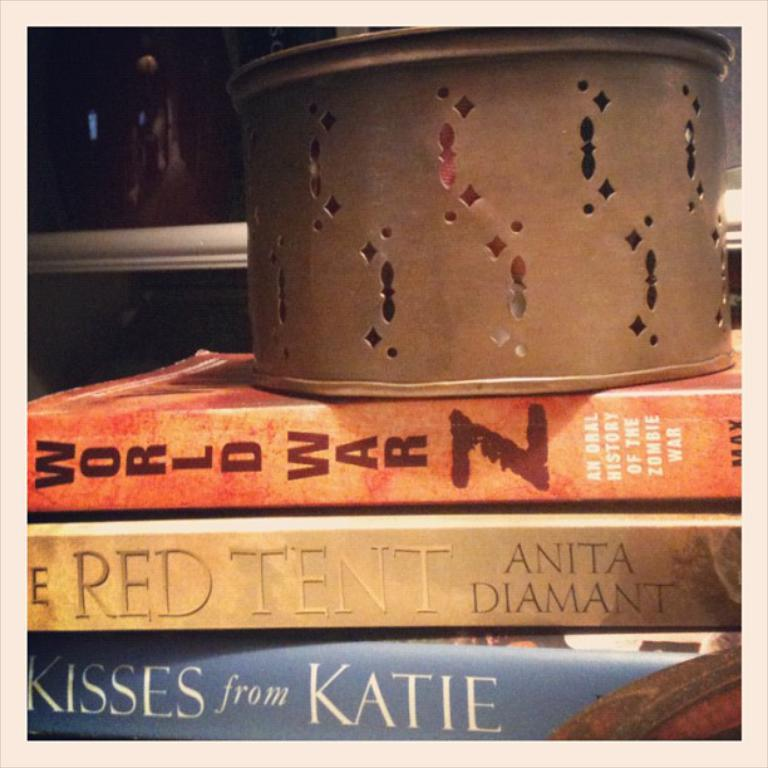<image>
Write a terse but informative summary of the picture. The books Words War Z, The Red Tent, and Kisses from Katie stacked together underneath a container. 